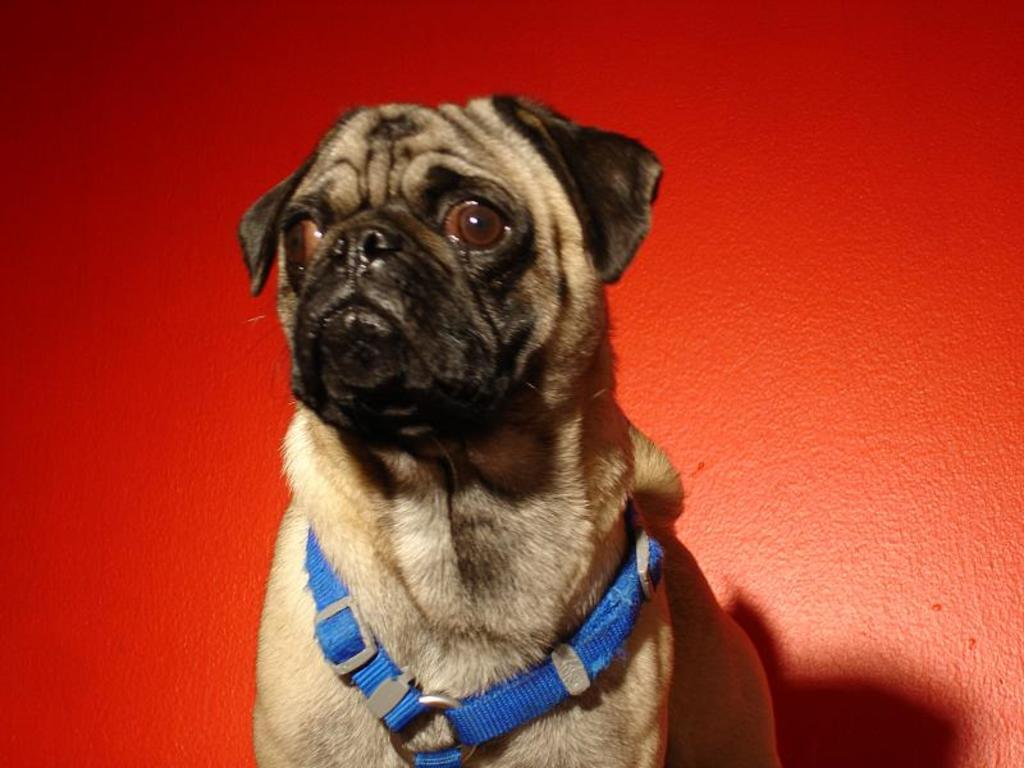What type of animal is present in the image? There is a dog in the image. What is the dog wearing? The dog is wearing a blue color belt. What color is the wall in the background of the image? There is a red wall in the background of the image. Can you tell me how many kittens are sitting on the home in the image? There are no kittens or homes present in the image; it features a dog wearing a blue color belt in front of a red wall. What type of stew is being prepared in the image? There is no stew or cooking activity present in the image. 